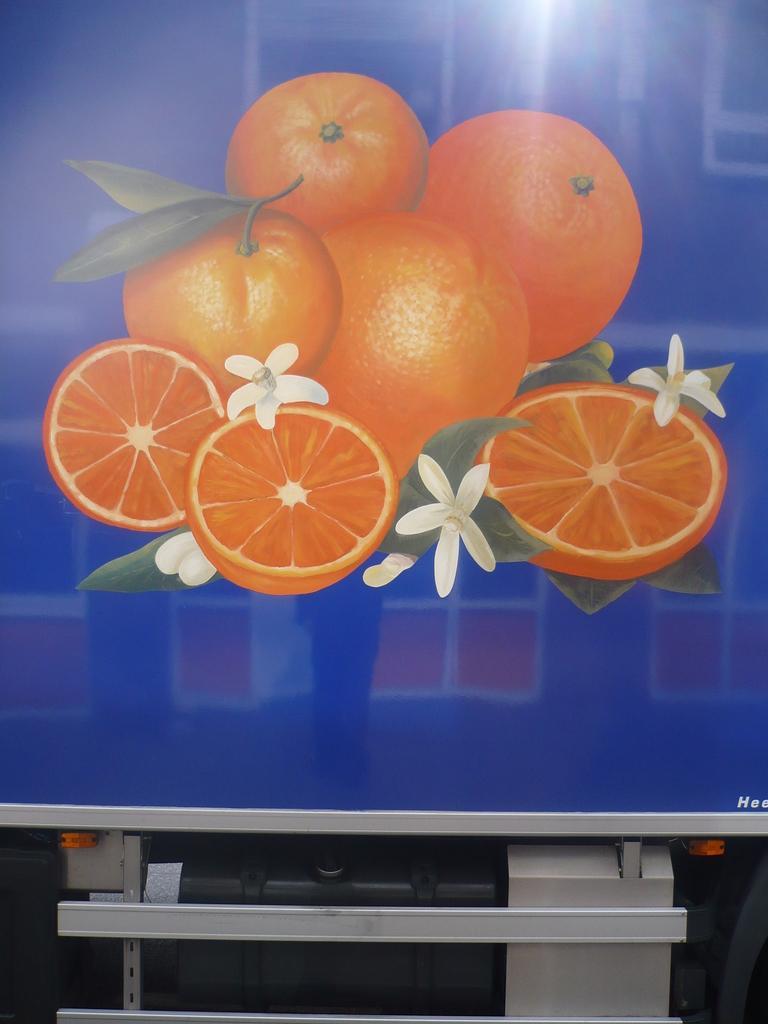How would you summarize this image in a sentence or two? In this image I can see oranges and flowers in a screen and metal rods. This image is taken may be in a hall. 